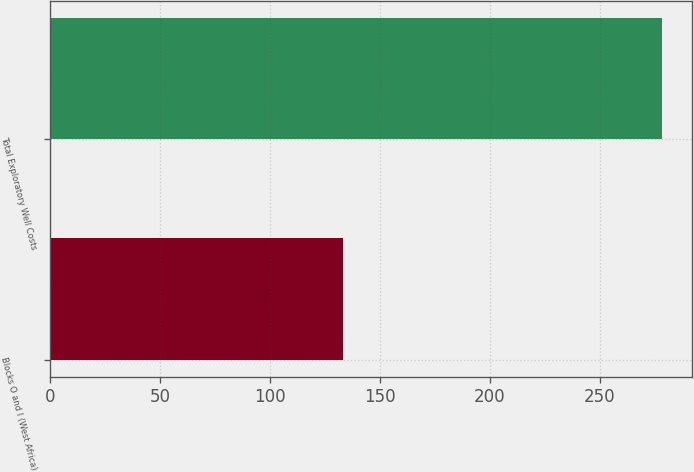Convert chart to OTSL. <chart><loc_0><loc_0><loc_500><loc_500><bar_chart><fcel>Blocks O and I (West Africa)<fcel>Total Exploratory Well Costs<nl><fcel>133<fcel>278<nl></chart> 